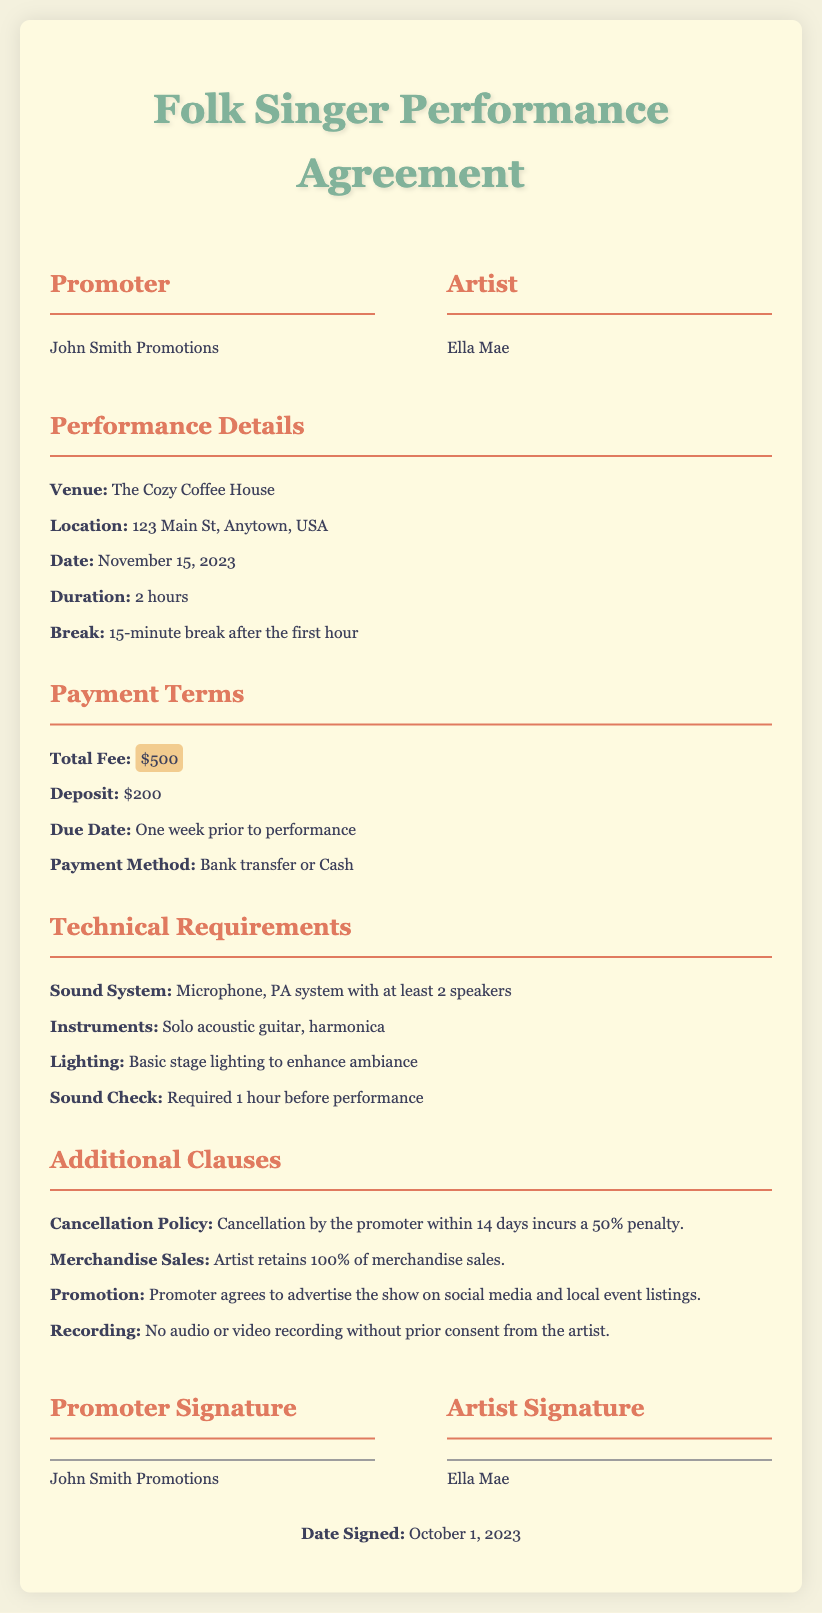What is the venue for the performance? The venue is specified in the document as The Cozy Coffee House.
Answer: The Cozy Coffee House What is the total fee for the performance? The document lists the total fee as $500.
Answer: $500 What is the duration of the performance? The duration is mentioned as 2 hours in the performance details section.
Answer: 2 hours What is the cancellation policy penalty? The penalty for cancellation by the promoter within 14 days is a 50% penalty, as stated in the additional clauses.
Answer: 50% What instruments will the artist use? The instruments that the artist will use are listed as solo acoustic guitar and harmonica.
Answer: Solo acoustic guitar, harmonica What must be done 1 hour before the performance? The document notes that a sound check is required 1 hour before the performance.
Answer: Sound Check What is the due date for the deposit payment? The due date for the deposit payment is one week prior to the performance date, as indicated in the payment terms.
Answer: One week prior to performance Who retains merchandise sales? The clause specifies that the artist retains 100% of merchandise sales.
Answer: Artist What type of recording is prohibited without consent? The document indicates that no audio or video recording is allowed without prior consent from the artist.
Answer: Audio or video recording 